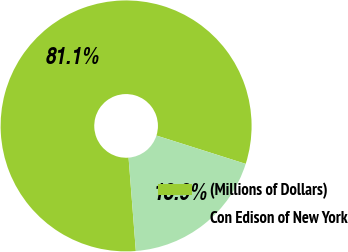<chart> <loc_0><loc_0><loc_500><loc_500><pie_chart><fcel>(Millions of Dollars)<fcel>Con Edison of New York<nl><fcel>81.13%<fcel>18.87%<nl></chart> 